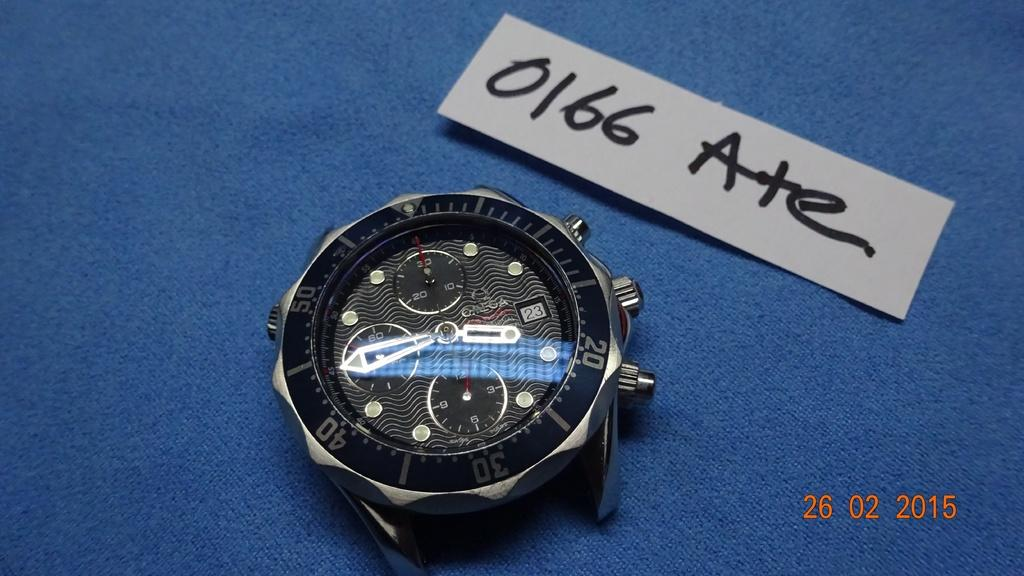Provide a one-sentence caption for the provided image. A black and silver watch with a paper above it with 0166 Ate on it. 